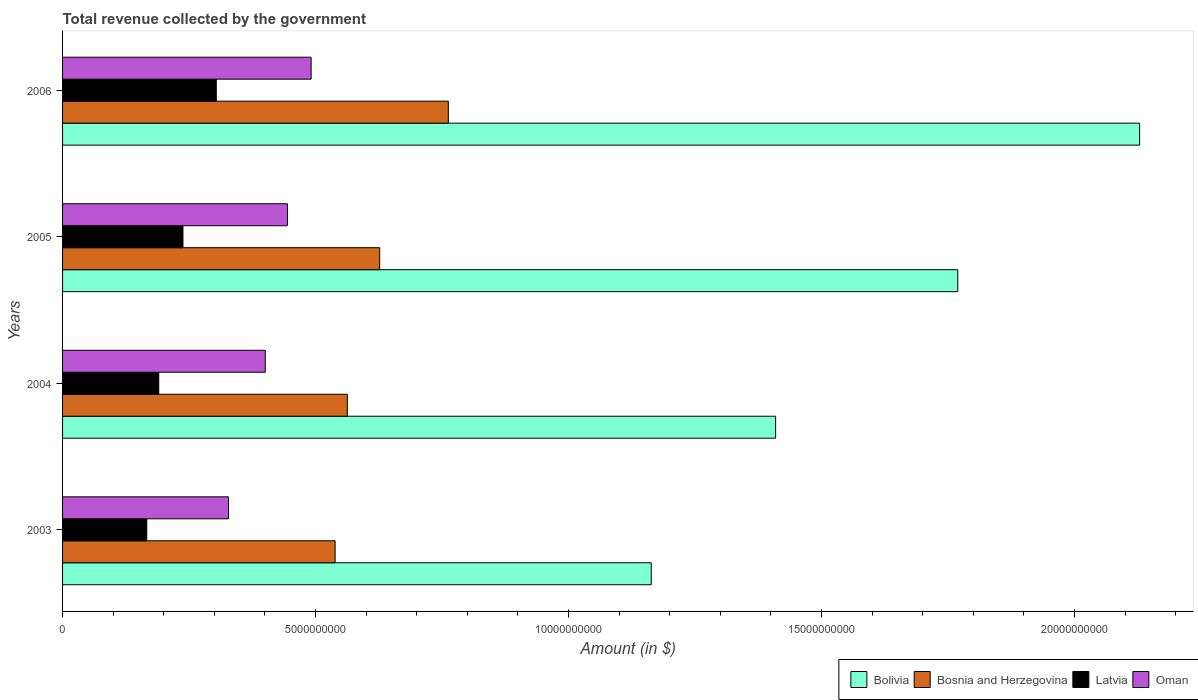How many groups of bars are there?
Your answer should be very brief. 4. Are the number of bars on each tick of the Y-axis equal?
Provide a succinct answer. Yes. How many bars are there on the 1st tick from the top?
Offer a terse response. 4. What is the total revenue collected by the government in Oman in 2006?
Give a very brief answer. 4.91e+09. Across all years, what is the maximum total revenue collected by the government in Bosnia and Herzegovina?
Ensure brevity in your answer.  7.62e+09. Across all years, what is the minimum total revenue collected by the government in Bolivia?
Offer a terse response. 1.16e+1. In which year was the total revenue collected by the government in Oman minimum?
Provide a succinct answer. 2003. What is the total total revenue collected by the government in Bolivia in the graph?
Provide a short and direct response. 6.47e+1. What is the difference between the total revenue collected by the government in Bosnia and Herzegovina in 2003 and that in 2005?
Keep it short and to the point. -8.80e+08. What is the difference between the total revenue collected by the government in Bosnia and Herzegovina in 2004 and the total revenue collected by the government in Oman in 2005?
Offer a very short reply. 1.18e+09. What is the average total revenue collected by the government in Latvia per year?
Provide a short and direct response. 2.25e+09. In the year 2003, what is the difference between the total revenue collected by the government in Bolivia and total revenue collected by the government in Latvia?
Your answer should be compact. 9.97e+09. What is the ratio of the total revenue collected by the government in Bolivia in 2003 to that in 2006?
Provide a succinct answer. 0.55. Is the total revenue collected by the government in Bosnia and Herzegovina in 2004 less than that in 2006?
Your answer should be very brief. Yes. Is the difference between the total revenue collected by the government in Bolivia in 2004 and 2006 greater than the difference between the total revenue collected by the government in Latvia in 2004 and 2006?
Your answer should be very brief. No. What is the difference between the highest and the second highest total revenue collected by the government in Latvia?
Provide a succinct answer. 6.58e+08. What is the difference between the highest and the lowest total revenue collected by the government in Latvia?
Make the answer very short. 1.37e+09. In how many years, is the total revenue collected by the government in Oman greater than the average total revenue collected by the government in Oman taken over all years?
Keep it short and to the point. 2. What does the 4th bar from the top in 2006 represents?
Keep it short and to the point. Bolivia. What does the 1st bar from the bottom in 2005 represents?
Keep it short and to the point. Bolivia. Is it the case that in every year, the sum of the total revenue collected by the government in Latvia and total revenue collected by the government in Bosnia and Herzegovina is greater than the total revenue collected by the government in Oman?
Ensure brevity in your answer.  Yes. How many bars are there?
Your response must be concise. 16. How many years are there in the graph?
Offer a terse response. 4. What is the difference between two consecutive major ticks on the X-axis?
Your response must be concise. 5.00e+09. Are the values on the major ticks of X-axis written in scientific E-notation?
Your answer should be very brief. No. Does the graph contain any zero values?
Offer a terse response. No. Does the graph contain grids?
Your response must be concise. No. What is the title of the graph?
Your answer should be compact. Total revenue collected by the government. Does "Caribbean small states" appear as one of the legend labels in the graph?
Your answer should be very brief. No. What is the label or title of the X-axis?
Your answer should be very brief. Amount (in $). What is the Amount (in $) of Bolivia in 2003?
Offer a terse response. 1.16e+1. What is the Amount (in $) of Bosnia and Herzegovina in 2003?
Offer a terse response. 5.39e+09. What is the Amount (in $) of Latvia in 2003?
Your answer should be compact. 1.66e+09. What is the Amount (in $) in Oman in 2003?
Your answer should be compact. 3.28e+09. What is the Amount (in $) of Bolivia in 2004?
Keep it short and to the point. 1.41e+1. What is the Amount (in $) of Bosnia and Herzegovina in 2004?
Ensure brevity in your answer.  5.63e+09. What is the Amount (in $) of Latvia in 2004?
Ensure brevity in your answer.  1.90e+09. What is the Amount (in $) of Oman in 2004?
Keep it short and to the point. 4.01e+09. What is the Amount (in $) in Bolivia in 2005?
Give a very brief answer. 1.77e+1. What is the Amount (in $) of Bosnia and Herzegovina in 2005?
Your answer should be very brief. 6.27e+09. What is the Amount (in $) in Latvia in 2005?
Provide a succinct answer. 2.38e+09. What is the Amount (in $) of Oman in 2005?
Provide a short and direct response. 4.44e+09. What is the Amount (in $) in Bolivia in 2006?
Offer a very short reply. 2.13e+1. What is the Amount (in $) in Bosnia and Herzegovina in 2006?
Give a very brief answer. 7.62e+09. What is the Amount (in $) in Latvia in 2006?
Keep it short and to the point. 3.04e+09. What is the Amount (in $) of Oman in 2006?
Provide a short and direct response. 4.91e+09. Across all years, what is the maximum Amount (in $) in Bolivia?
Offer a very short reply. 2.13e+1. Across all years, what is the maximum Amount (in $) of Bosnia and Herzegovina?
Your response must be concise. 7.62e+09. Across all years, what is the maximum Amount (in $) in Latvia?
Provide a short and direct response. 3.04e+09. Across all years, what is the maximum Amount (in $) of Oman?
Ensure brevity in your answer.  4.91e+09. Across all years, what is the minimum Amount (in $) of Bolivia?
Provide a short and direct response. 1.16e+1. Across all years, what is the minimum Amount (in $) of Bosnia and Herzegovina?
Your answer should be very brief. 5.39e+09. Across all years, what is the minimum Amount (in $) in Latvia?
Your answer should be compact. 1.66e+09. Across all years, what is the minimum Amount (in $) of Oman?
Ensure brevity in your answer.  3.28e+09. What is the total Amount (in $) in Bolivia in the graph?
Keep it short and to the point. 6.47e+1. What is the total Amount (in $) in Bosnia and Herzegovina in the graph?
Offer a very short reply. 2.49e+1. What is the total Amount (in $) in Latvia in the graph?
Provide a short and direct response. 8.98e+09. What is the total Amount (in $) of Oman in the graph?
Keep it short and to the point. 1.66e+1. What is the difference between the Amount (in $) in Bolivia in 2003 and that in 2004?
Provide a succinct answer. -2.46e+09. What is the difference between the Amount (in $) of Bosnia and Herzegovina in 2003 and that in 2004?
Make the answer very short. -2.41e+08. What is the difference between the Amount (in $) in Latvia in 2003 and that in 2004?
Ensure brevity in your answer.  -2.37e+08. What is the difference between the Amount (in $) of Oman in 2003 and that in 2004?
Provide a succinct answer. -7.26e+08. What is the difference between the Amount (in $) in Bolivia in 2003 and that in 2005?
Your answer should be compact. -6.06e+09. What is the difference between the Amount (in $) in Bosnia and Herzegovina in 2003 and that in 2005?
Your answer should be compact. -8.80e+08. What is the difference between the Amount (in $) in Latvia in 2003 and that in 2005?
Provide a short and direct response. -7.15e+08. What is the difference between the Amount (in $) in Oman in 2003 and that in 2005?
Your answer should be very brief. -1.16e+09. What is the difference between the Amount (in $) in Bolivia in 2003 and that in 2006?
Provide a succinct answer. -9.65e+09. What is the difference between the Amount (in $) of Bosnia and Herzegovina in 2003 and that in 2006?
Your response must be concise. -2.24e+09. What is the difference between the Amount (in $) in Latvia in 2003 and that in 2006?
Offer a very short reply. -1.37e+09. What is the difference between the Amount (in $) in Oman in 2003 and that in 2006?
Provide a short and direct response. -1.63e+09. What is the difference between the Amount (in $) in Bolivia in 2004 and that in 2005?
Ensure brevity in your answer.  -3.60e+09. What is the difference between the Amount (in $) of Bosnia and Herzegovina in 2004 and that in 2005?
Your response must be concise. -6.39e+08. What is the difference between the Amount (in $) in Latvia in 2004 and that in 2005?
Make the answer very short. -4.78e+08. What is the difference between the Amount (in $) of Oman in 2004 and that in 2005?
Provide a succinct answer. -4.38e+08. What is the difference between the Amount (in $) of Bolivia in 2004 and that in 2006?
Offer a very short reply. -7.20e+09. What is the difference between the Amount (in $) of Bosnia and Herzegovina in 2004 and that in 2006?
Offer a terse response. -2.00e+09. What is the difference between the Amount (in $) of Latvia in 2004 and that in 2006?
Keep it short and to the point. -1.14e+09. What is the difference between the Amount (in $) in Oman in 2004 and that in 2006?
Your response must be concise. -9.07e+08. What is the difference between the Amount (in $) of Bolivia in 2005 and that in 2006?
Keep it short and to the point. -3.59e+09. What is the difference between the Amount (in $) of Bosnia and Herzegovina in 2005 and that in 2006?
Provide a succinct answer. -1.36e+09. What is the difference between the Amount (in $) of Latvia in 2005 and that in 2006?
Ensure brevity in your answer.  -6.58e+08. What is the difference between the Amount (in $) of Oman in 2005 and that in 2006?
Offer a terse response. -4.69e+08. What is the difference between the Amount (in $) of Bolivia in 2003 and the Amount (in $) of Bosnia and Herzegovina in 2004?
Your answer should be very brief. 6.01e+09. What is the difference between the Amount (in $) of Bolivia in 2003 and the Amount (in $) of Latvia in 2004?
Offer a very short reply. 9.73e+09. What is the difference between the Amount (in $) in Bolivia in 2003 and the Amount (in $) in Oman in 2004?
Ensure brevity in your answer.  7.63e+09. What is the difference between the Amount (in $) of Bosnia and Herzegovina in 2003 and the Amount (in $) of Latvia in 2004?
Provide a succinct answer. 3.49e+09. What is the difference between the Amount (in $) of Bosnia and Herzegovina in 2003 and the Amount (in $) of Oman in 2004?
Provide a short and direct response. 1.38e+09. What is the difference between the Amount (in $) in Latvia in 2003 and the Amount (in $) in Oman in 2004?
Provide a short and direct response. -2.34e+09. What is the difference between the Amount (in $) in Bolivia in 2003 and the Amount (in $) in Bosnia and Herzegovina in 2005?
Provide a succinct answer. 5.37e+09. What is the difference between the Amount (in $) in Bolivia in 2003 and the Amount (in $) in Latvia in 2005?
Provide a short and direct response. 9.26e+09. What is the difference between the Amount (in $) of Bolivia in 2003 and the Amount (in $) of Oman in 2005?
Your answer should be compact. 7.19e+09. What is the difference between the Amount (in $) in Bosnia and Herzegovina in 2003 and the Amount (in $) in Latvia in 2005?
Make the answer very short. 3.01e+09. What is the difference between the Amount (in $) of Bosnia and Herzegovina in 2003 and the Amount (in $) of Oman in 2005?
Provide a succinct answer. 9.44e+08. What is the difference between the Amount (in $) in Latvia in 2003 and the Amount (in $) in Oman in 2005?
Make the answer very short. -2.78e+09. What is the difference between the Amount (in $) in Bolivia in 2003 and the Amount (in $) in Bosnia and Herzegovina in 2006?
Provide a short and direct response. 4.01e+09. What is the difference between the Amount (in $) of Bolivia in 2003 and the Amount (in $) of Latvia in 2006?
Provide a short and direct response. 8.60e+09. What is the difference between the Amount (in $) of Bolivia in 2003 and the Amount (in $) of Oman in 2006?
Your response must be concise. 6.72e+09. What is the difference between the Amount (in $) of Bosnia and Herzegovina in 2003 and the Amount (in $) of Latvia in 2006?
Keep it short and to the point. 2.35e+09. What is the difference between the Amount (in $) in Bosnia and Herzegovina in 2003 and the Amount (in $) in Oman in 2006?
Keep it short and to the point. 4.75e+08. What is the difference between the Amount (in $) in Latvia in 2003 and the Amount (in $) in Oman in 2006?
Provide a short and direct response. -3.25e+09. What is the difference between the Amount (in $) of Bolivia in 2004 and the Amount (in $) of Bosnia and Herzegovina in 2005?
Make the answer very short. 7.83e+09. What is the difference between the Amount (in $) of Bolivia in 2004 and the Amount (in $) of Latvia in 2005?
Keep it short and to the point. 1.17e+1. What is the difference between the Amount (in $) of Bolivia in 2004 and the Amount (in $) of Oman in 2005?
Ensure brevity in your answer.  9.65e+09. What is the difference between the Amount (in $) of Bosnia and Herzegovina in 2004 and the Amount (in $) of Latvia in 2005?
Ensure brevity in your answer.  3.25e+09. What is the difference between the Amount (in $) of Bosnia and Herzegovina in 2004 and the Amount (in $) of Oman in 2005?
Your response must be concise. 1.18e+09. What is the difference between the Amount (in $) in Latvia in 2004 and the Amount (in $) in Oman in 2005?
Make the answer very short. -2.54e+09. What is the difference between the Amount (in $) of Bolivia in 2004 and the Amount (in $) of Bosnia and Herzegovina in 2006?
Give a very brief answer. 6.47e+09. What is the difference between the Amount (in $) of Bolivia in 2004 and the Amount (in $) of Latvia in 2006?
Provide a short and direct response. 1.11e+1. What is the difference between the Amount (in $) in Bolivia in 2004 and the Amount (in $) in Oman in 2006?
Provide a short and direct response. 9.18e+09. What is the difference between the Amount (in $) in Bosnia and Herzegovina in 2004 and the Amount (in $) in Latvia in 2006?
Your answer should be compact. 2.59e+09. What is the difference between the Amount (in $) of Bosnia and Herzegovina in 2004 and the Amount (in $) of Oman in 2006?
Your answer should be compact. 7.16e+08. What is the difference between the Amount (in $) in Latvia in 2004 and the Amount (in $) in Oman in 2006?
Offer a terse response. -3.01e+09. What is the difference between the Amount (in $) in Bolivia in 2005 and the Amount (in $) in Bosnia and Herzegovina in 2006?
Provide a succinct answer. 1.01e+1. What is the difference between the Amount (in $) in Bolivia in 2005 and the Amount (in $) in Latvia in 2006?
Offer a terse response. 1.47e+1. What is the difference between the Amount (in $) in Bolivia in 2005 and the Amount (in $) in Oman in 2006?
Offer a very short reply. 1.28e+1. What is the difference between the Amount (in $) in Bosnia and Herzegovina in 2005 and the Amount (in $) in Latvia in 2006?
Provide a succinct answer. 3.23e+09. What is the difference between the Amount (in $) in Bosnia and Herzegovina in 2005 and the Amount (in $) in Oman in 2006?
Offer a terse response. 1.35e+09. What is the difference between the Amount (in $) of Latvia in 2005 and the Amount (in $) of Oman in 2006?
Your answer should be very brief. -2.53e+09. What is the average Amount (in $) in Bolivia per year?
Provide a short and direct response. 1.62e+1. What is the average Amount (in $) in Bosnia and Herzegovina per year?
Ensure brevity in your answer.  6.23e+09. What is the average Amount (in $) in Latvia per year?
Give a very brief answer. 2.25e+09. What is the average Amount (in $) of Oman per year?
Make the answer very short. 4.16e+09. In the year 2003, what is the difference between the Amount (in $) of Bolivia and Amount (in $) of Bosnia and Herzegovina?
Give a very brief answer. 6.25e+09. In the year 2003, what is the difference between the Amount (in $) in Bolivia and Amount (in $) in Latvia?
Provide a short and direct response. 9.97e+09. In the year 2003, what is the difference between the Amount (in $) in Bolivia and Amount (in $) in Oman?
Your response must be concise. 8.35e+09. In the year 2003, what is the difference between the Amount (in $) in Bosnia and Herzegovina and Amount (in $) in Latvia?
Ensure brevity in your answer.  3.72e+09. In the year 2003, what is the difference between the Amount (in $) of Bosnia and Herzegovina and Amount (in $) of Oman?
Your response must be concise. 2.11e+09. In the year 2003, what is the difference between the Amount (in $) of Latvia and Amount (in $) of Oman?
Your answer should be compact. -1.62e+09. In the year 2004, what is the difference between the Amount (in $) in Bolivia and Amount (in $) in Bosnia and Herzegovina?
Provide a succinct answer. 8.47e+09. In the year 2004, what is the difference between the Amount (in $) in Bolivia and Amount (in $) in Latvia?
Your response must be concise. 1.22e+1. In the year 2004, what is the difference between the Amount (in $) of Bolivia and Amount (in $) of Oman?
Your answer should be very brief. 1.01e+1. In the year 2004, what is the difference between the Amount (in $) of Bosnia and Herzegovina and Amount (in $) of Latvia?
Provide a short and direct response. 3.73e+09. In the year 2004, what is the difference between the Amount (in $) in Bosnia and Herzegovina and Amount (in $) in Oman?
Provide a succinct answer. 1.62e+09. In the year 2004, what is the difference between the Amount (in $) of Latvia and Amount (in $) of Oman?
Keep it short and to the point. -2.10e+09. In the year 2005, what is the difference between the Amount (in $) in Bolivia and Amount (in $) in Bosnia and Herzegovina?
Your answer should be compact. 1.14e+1. In the year 2005, what is the difference between the Amount (in $) of Bolivia and Amount (in $) of Latvia?
Your answer should be very brief. 1.53e+1. In the year 2005, what is the difference between the Amount (in $) in Bolivia and Amount (in $) in Oman?
Your response must be concise. 1.33e+1. In the year 2005, what is the difference between the Amount (in $) of Bosnia and Herzegovina and Amount (in $) of Latvia?
Your response must be concise. 3.89e+09. In the year 2005, what is the difference between the Amount (in $) of Bosnia and Herzegovina and Amount (in $) of Oman?
Offer a terse response. 1.82e+09. In the year 2005, what is the difference between the Amount (in $) in Latvia and Amount (in $) in Oman?
Offer a very short reply. -2.06e+09. In the year 2006, what is the difference between the Amount (in $) of Bolivia and Amount (in $) of Bosnia and Herzegovina?
Offer a very short reply. 1.37e+1. In the year 2006, what is the difference between the Amount (in $) of Bolivia and Amount (in $) of Latvia?
Offer a very short reply. 1.83e+1. In the year 2006, what is the difference between the Amount (in $) in Bolivia and Amount (in $) in Oman?
Ensure brevity in your answer.  1.64e+1. In the year 2006, what is the difference between the Amount (in $) in Bosnia and Herzegovina and Amount (in $) in Latvia?
Ensure brevity in your answer.  4.59e+09. In the year 2006, what is the difference between the Amount (in $) in Bosnia and Herzegovina and Amount (in $) in Oman?
Keep it short and to the point. 2.71e+09. In the year 2006, what is the difference between the Amount (in $) of Latvia and Amount (in $) of Oman?
Your answer should be very brief. -1.87e+09. What is the ratio of the Amount (in $) in Bolivia in 2003 to that in 2004?
Your answer should be very brief. 0.83. What is the ratio of the Amount (in $) of Bosnia and Herzegovina in 2003 to that in 2004?
Give a very brief answer. 0.96. What is the ratio of the Amount (in $) of Latvia in 2003 to that in 2004?
Your answer should be compact. 0.88. What is the ratio of the Amount (in $) of Oman in 2003 to that in 2004?
Keep it short and to the point. 0.82. What is the ratio of the Amount (in $) of Bolivia in 2003 to that in 2005?
Offer a very short reply. 0.66. What is the ratio of the Amount (in $) in Bosnia and Herzegovina in 2003 to that in 2005?
Provide a succinct answer. 0.86. What is the ratio of the Amount (in $) of Latvia in 2003 to that in 2005?
Offer a terse response. 0.7. What is the ratio of the Amount (in $) of Oman in 2003 to that in 2005?
Keep it short and to the point. 0.74. What is the ratio of the Amount (in $) in Bolivia in 2003 to that in 2006?
Make the answer very short. 0.55. What is the ratio of the Amount (in $) in Bosnia and Herzegovina in 2003 to that in 2006?
Your response must be concise. 0.71. What is the ratio of the Amount (in $) in Latvia in 2003 to that in 2006?
Provide a short and direct response. 0.55. What is the ratio of the Amount (in $) in Oman in 2003 to that in 2006?
Your response must be concise. 0.67. What is the ratio of the Amount (in $) of Bolivia in 2004 to that in 2005?
Provide a succinct answer. 0.8. What is the ratio of the Amount (in $) of Bosnia and Herzegovina in 2004 to that in 2005?
Your answer should be very brief. 0.9. What is the ratio of the Amount (in $) in Latvia in 2004 to that in 2005?
Give a very brief answer. 0.8. What is the ratio of the Amount (in $) of Oman in 2004 to that in 2005?
Provide a short and direct response. 0.9. What is the ratio of the Amount (in $) of Bolivia in 2004 to that in 2006?
Your answer should be very brief. 0.66. What is the ratio of the Amount (in $) of Bosnia and Herzegovina in 2004 to that in 2006?
Provide a short and direct response. 0.74. What is the ratio of the Amount (in $) of Latvia in 2004 to that in 2006?
Give a very brief answer. 0.63. What is the ratio of the Amount (in $) in Oman in 2004 to that in 2006?
Your answer should be very brief. 0.82. What is the ratio of the Amount (in $) in Bolivia in 2005 to that in 2006?
Ensure brevity in your answer.  0.83. What is the ratio of the Amount (in $) in Bosnia and Herzegovina in 2005 to that in 2006?
Your response must be concise. 0.82. What is the ratio of the Amount (in $) of Latvia in 2005 to that in 2006?
Make the answer very short. 0.78. What is the ratio of the Amount (in $) of Oman in 2005 to that in 2006?
Provide a succinct answer. 0.9. What is the difference between the highest and the second highest Amount (in $) of Bolivia?
Keep it short and to the point. 3.59e+09. What is the difference between the highest and the second highest Amount (in $) of Bosnia and Herzegovina?
Give a very brief answer. 1.36e+09. What is the difference between the highest and the second highest Amount (in $) of Latvia?
Offer a terse response. 6.58e+08. What is the difference between the highest and the second highest Amount (in $) of Oman?
Provide a succinct answer. 4.69e+08. What is the difference between the highest and the lowest Amount (in $) of Bolivia?
Your answer should be very brief. 9.65e+09. What is the difference between the highest and the lowest Amount (in $) in Bosnia and Herzegovina?
Your answer should be compact. 2.24e+09. What is the difference between the highest and the lowest Amount (in $) of Latvia?
Offer a very short reply. 1.37e+09. What is the difference between the highest and the lowest Amount (in $) of Oman?
Offer a terse response. 1.63e+09. 